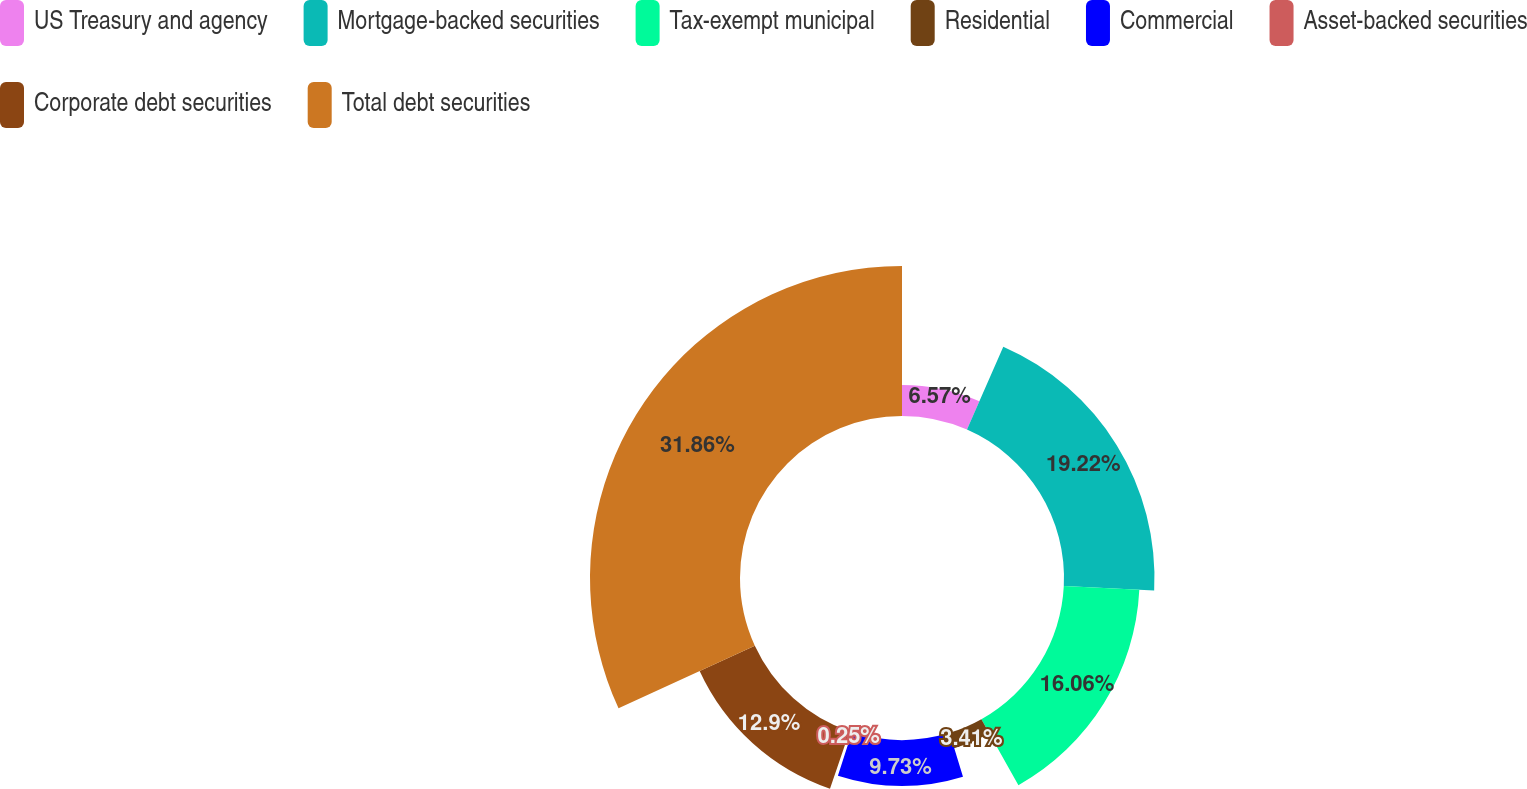Convert chart to OTSL. <chart><loc_0><loc_0><loc_500><loc_500><pie_chart><fcel>US Treasury and agency<fcel>Mortgage-backed securities<fcel>Tax-exempt municipal<fcel>Residential<fcel>Commercial<fcel>Asset-backed securities<fcel>Corporate debt securities<fcel>Total debt securities<nl><fcel>6.57%<fcel>19.22%<fcel>16.06%<fcel>3.41%<fcel>9.73%<fcel>0.25%<fcel>12.9%<fcel>31.86%<nl></chart> 